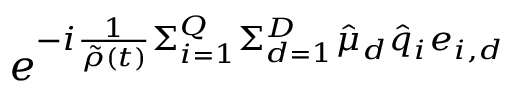Convert formula to latex. <formula><loc_0><loc_0><loc_500><loc_500>e ^ { - i \frac { 1 } { \tilde { \rho } ( t ) } \Sigma _ { i = 1 } ^ { Q } \Sigma _ { d = 1 } ^ { D } \hat { \mu } _ { d } \hat { q } _ { i } e _ { i , d } }</formula> 